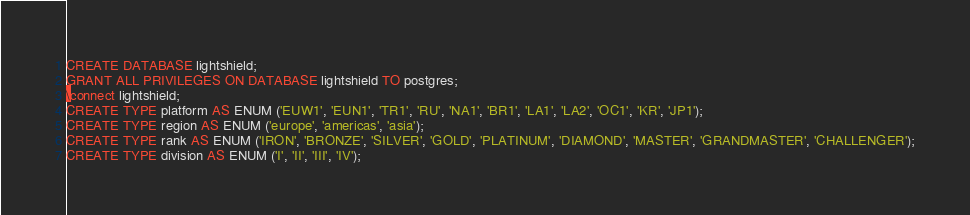Convert code to text. <code><loc_0><loc_0><loc_500><loc_500><_SQL_>CREATE DATABASE lightshield;
GRANT ALL PRIVILEGES ON DATABASE lightshield TO postgres;
\connect lightshield;
CREATE TYPE platform AS ENUM ('EUW1', 'EUN1', 'TR1', 'RU', 'NA1', 'BR1', 'LA1', 'LA2', 'OC1', 'KR', 'JP1');
CREATE TYPE region AS ENUM ('europe', 'americas', 'asia');
CREATE TYPE rank AS ENUM ('IRON', 'BRONZE', 'SILVER', 'GOLD', 'PLATINUM', 'DIAMOND', 'MASTER', 'GRANDMASTER', 'CHALLENGER');
CREATE TYPE division AS ENUM ('I', 'II', 'III', 'IV');
</code> 